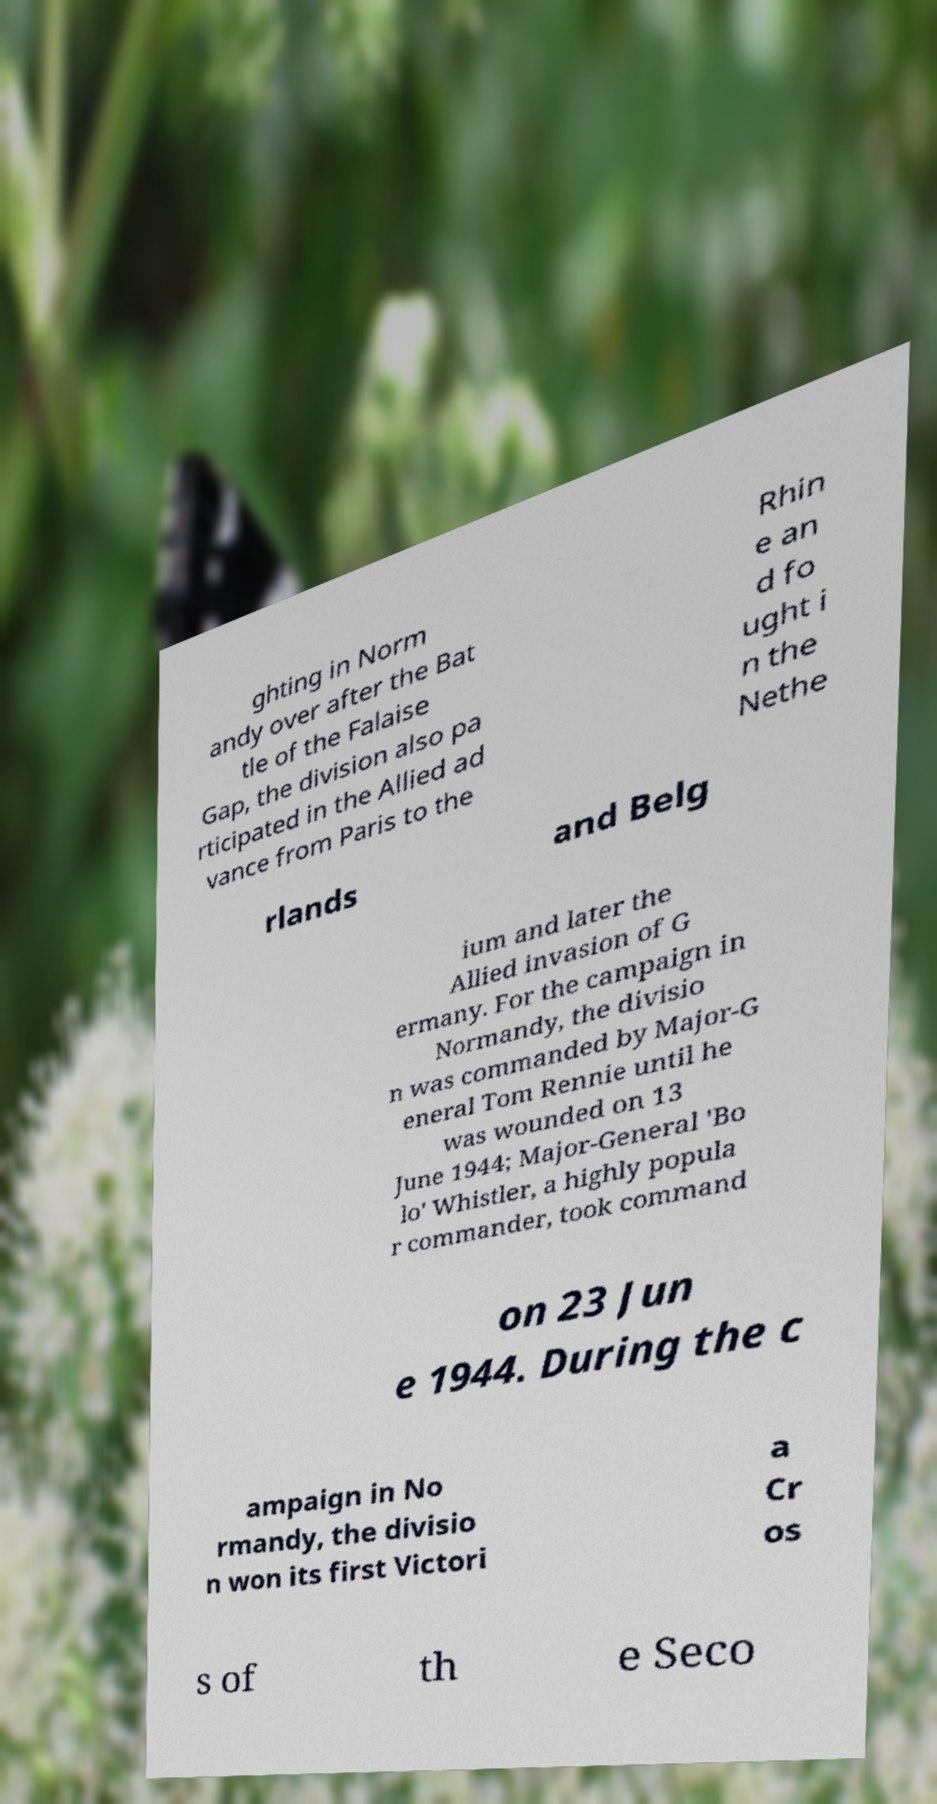Could you extract and type out the text from this image? ghting in Norm andy over after the Bat tle of the Falaise Gap, the division also pa rticipated in the Allied ad vance from Paris to the Rhin e an d fo ught i n the Nethe rlands and Belg ium and later the Allied invasion of G ermany. For the campaign in Normandy, the divisio n was commanded by Major-G eneral Tom Rennie until he was wounded on 13 June 1944; Major-General 'Bo lo' Whistler, a highly popula r commander, took command on 23 Jun e 1944. During the c ampaign in No rmandy, the divisio n won its first Victori a Cr os s of th e Seco 